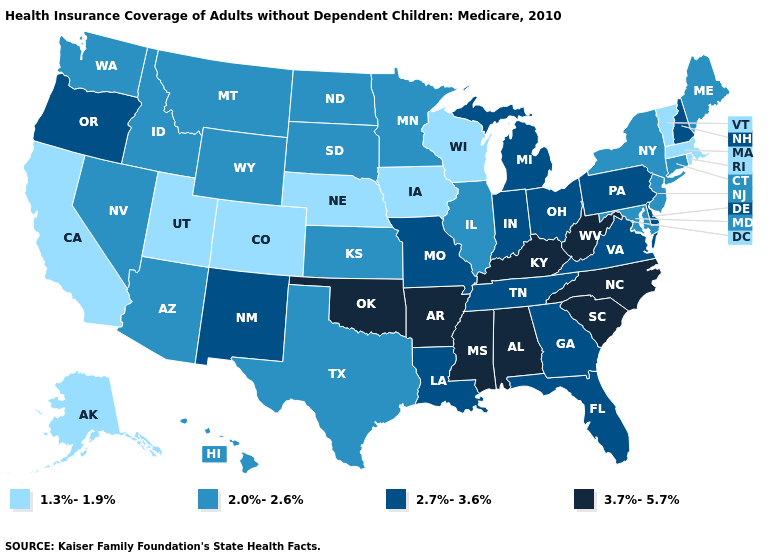Name the states that have a value in the range 2.7%-3.6%?
Keep it brief. Delaware, Florida, Georgia, Indiana, Louisiana, Michigan, Missouri, New Hampshire, New Mexico, Ohio, Oregon, Pennsylvania, Tennessee, Virginia. What is the value of New Hampshire?
Short answer required. 2.7%-3.6%. What is the lowest value in the West?
Keep it brief. 1.3%-1.9%. What is the lowest value in states that border Colorado?
Write a very short answer. 1.3%-1.9%. What is the lowest value in the South?
Write a very short answer. 2.0%-2.6%. What is the highest value in the Northeast ?
Concise answer only. 2.7%-3.6%. What is the highest value in the USA?
Write a very short answer. 3.7%-5.7%. Name the states that have a value in the range 3.7%-5.7%?
Answer briefly. Alabama, Arkansas, Kentucky, Mississippi, North Carolina, Oklahoma, South Carolina, West Virginia. What is the highest value in states that border Maryland?
Write a very short answer. 3.7%-5.7%. Name the states that have a value in the range 3.7%-5.7%?
Answer briefly. Alabama, Arkansas, Kentucky, Mississippi, North Carolina, Oklahoma, South Carolina, West Virginia. Name the states that have a value in the range 3.7%-5.7%?
Concise answer only. Alabama, Arkansas, Kentucky, Mississippi, North Carolina, Oklahoma, South Carolina, West Virginia. What is the lowest value in the Northeast?
Concise answer only. 1.3%-1.9%. Does Arkansas have the highest value in the USA?
Write a very short answer. Yes. Name the states that have a value in the range 1.3%-1.9%?
Answer briefly. Alaska, California, Colorado, Iowa, Massachusetts, Nebraska, Rhode Island, Utah, Vermont, Wisconsin. What is the lowest value in states that border Tennessee?
Keep it brief. 2.7%-3.6%. 